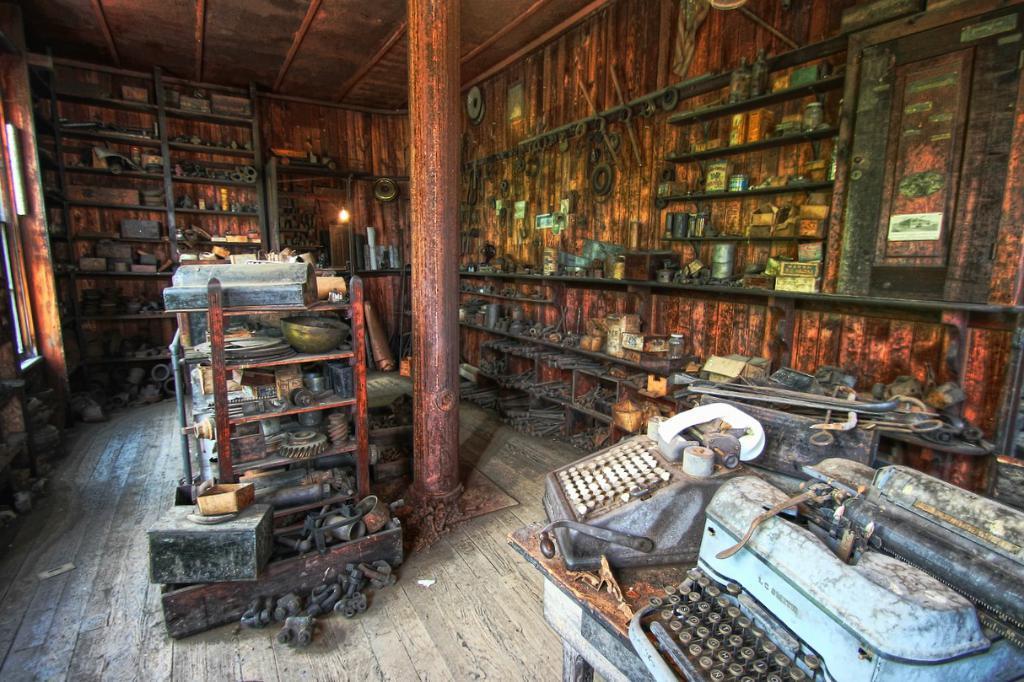In one or two sentences, can you explain what this image depicts? In this picture we can see some racks, there are some things present on these racks, at the right bottom we can see typing machines, there is a pillar here, in the middle we can see metallic things. 